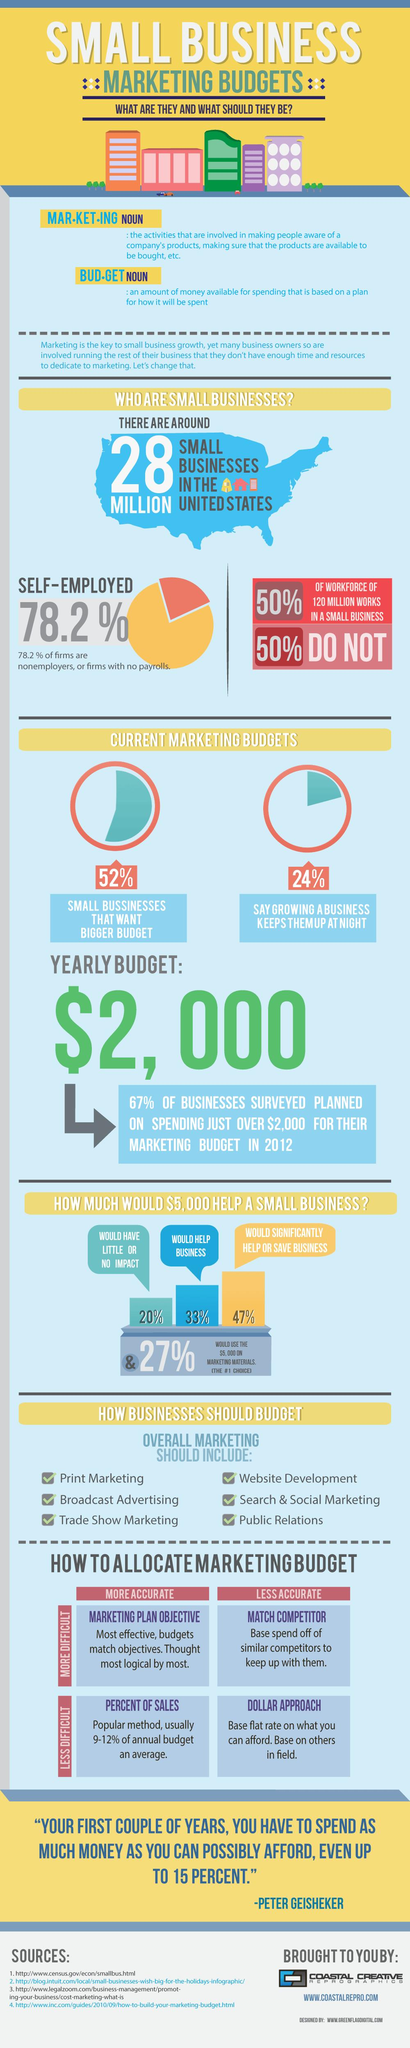Give some essential details in this illustration. The survey results show that 21.8% of the population is not self-employed. The color of the US map shown is blue. A majority of small businesses, approximately 47%, would benefit from receiving $5,000 in financial assistance. The words belong to Peter Geisheker. 